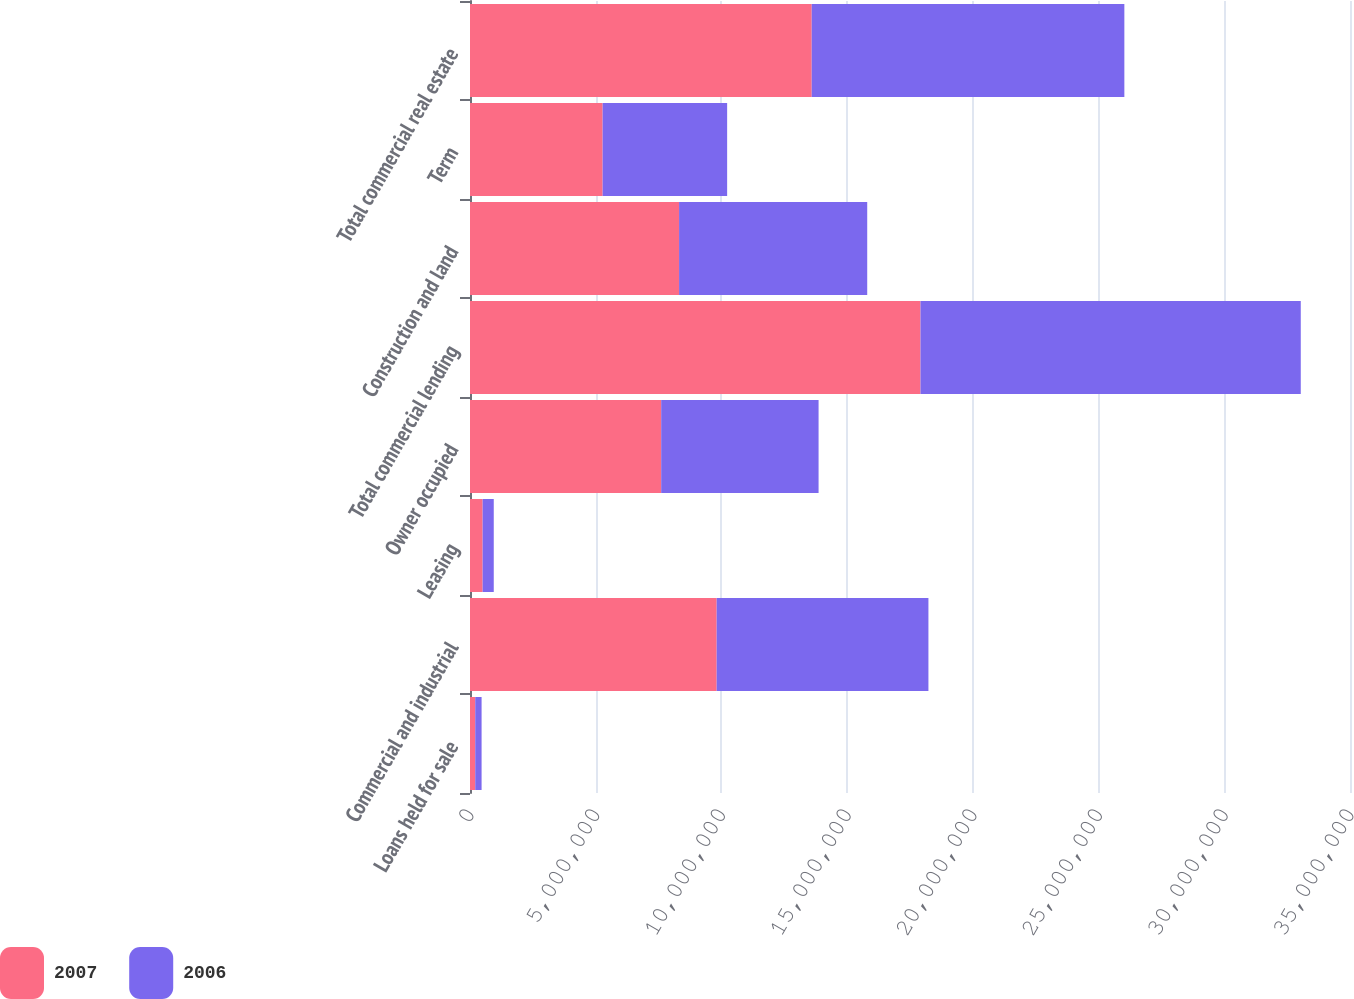<chart> <loc_0><loc_0><loc_500><loc_500><stacked_bar_chart><ecel><fcel>Loans held for sale<fcel>Commercial and industrial<fcel>Leasing<fcel>Owner occupied<fcel>Total commercial lending<fcel>Construction and land<fcel>Term<fcel>Total commercial real estate<nl><fcel>2007<fcel>207943<fcel>9.81099e+06<fcel>502601<fcel>7.60373e+06<fcel>1.79173e+07<fcel>8.31553e+06<fcel>5.27558e+06<fcel>1.35911e+07<nl><fcel>2006<fcel>252818<fcel>8.42209e+06<fcel>442440<fcel>6.26022e+06<fcel>1.51248e+07<fcel>7.4829e+06<fcel>4.95165e+06<fcel>1.24346e+07<nl></chart> 